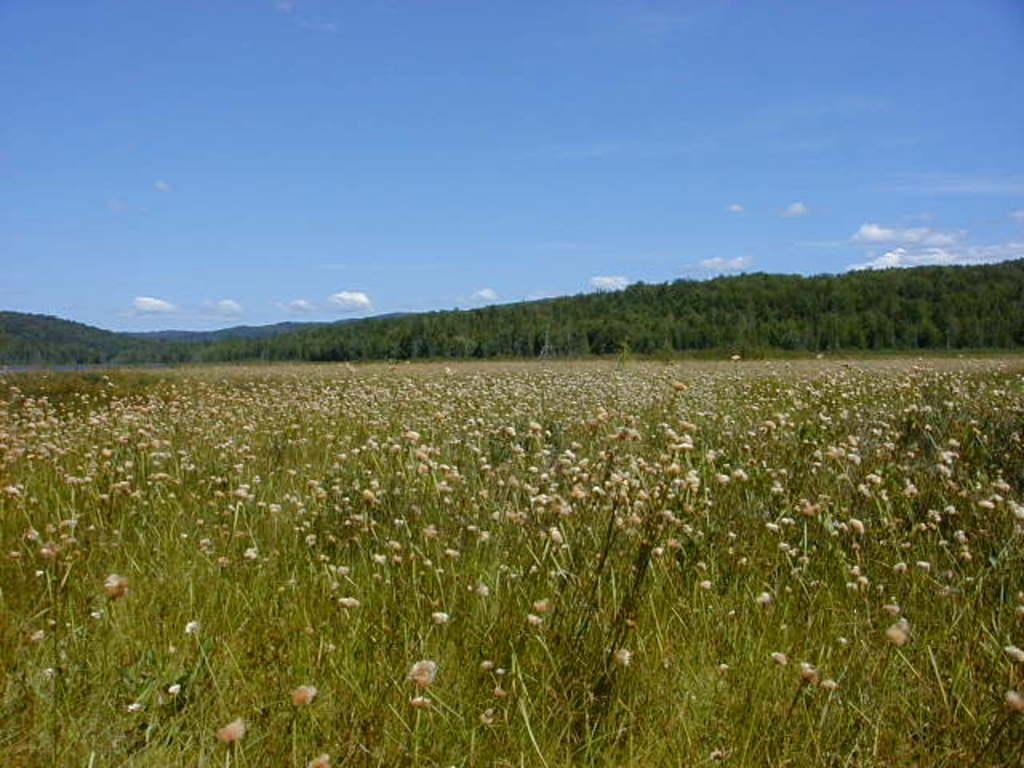What can be seen in the foreground of the image? There are flowers on plants in the foreground of the image. What is visible in the background of the image? There is a group of trees and mountains visible in the background of the image. How would you describe the sky in the image? The sky is cloudy in the background of the image. Are there any pets visible in the image? There are no pets present in the image. What type of canvas is being used by the laborer in the image? There is no laborer or canvas present in the image. 